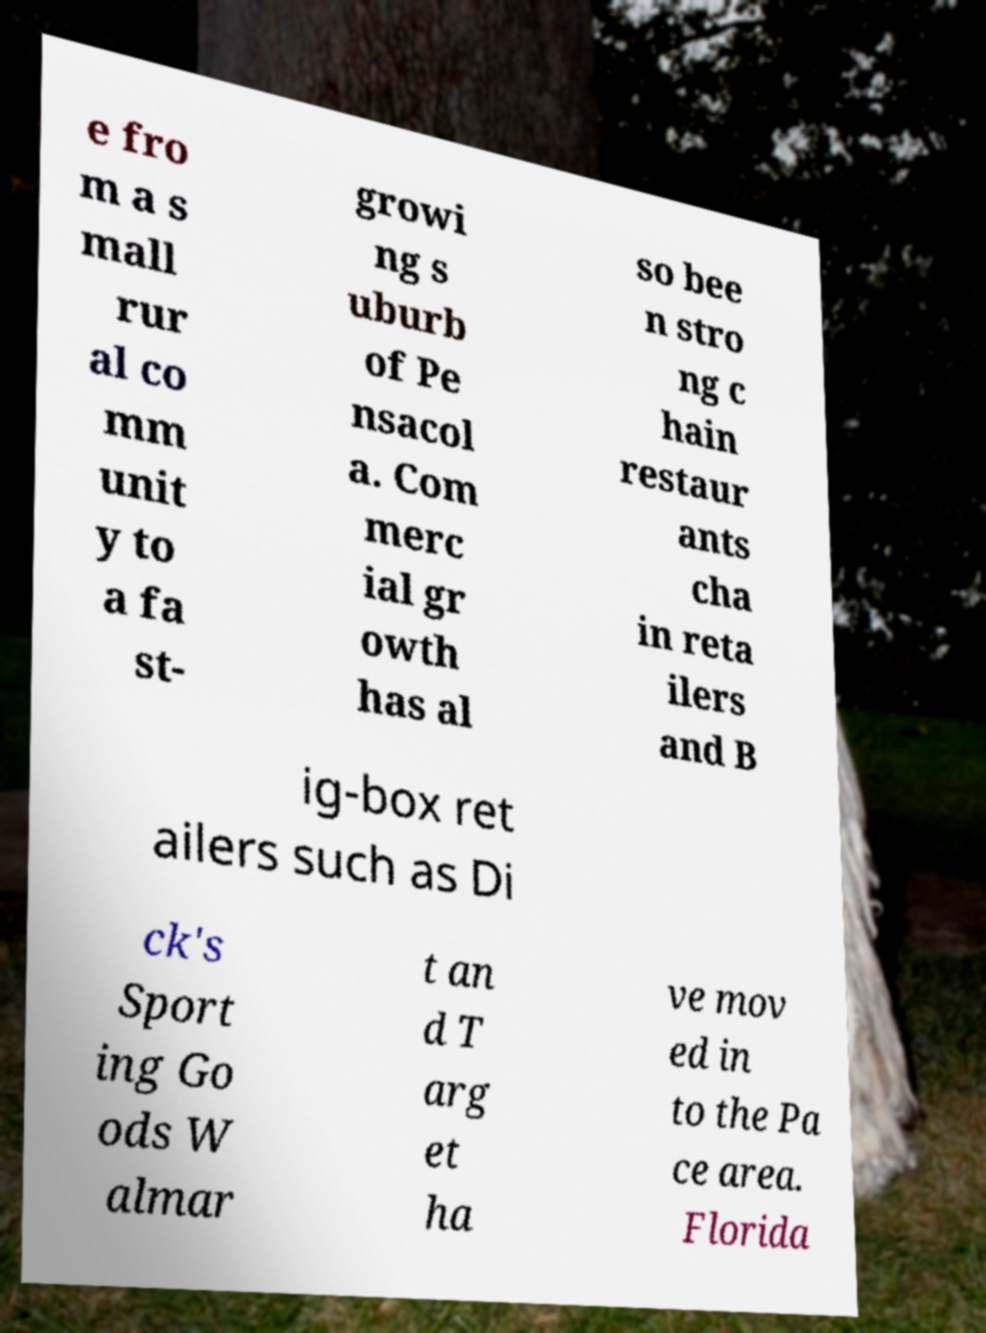Please identify and transcribe the text found in this image. e fro m a s mall rur al co mm unit y to a fa st- growi ng s uburb of Pe nsacol a. Com merc ial gr owth has al so bee n stro ng c hain restaur ants cha in reta ilers and B ig-box ret ailers such as Di ck's Sport ing Go ods W almar t an d T arg et ha ve mov ed in to the Pa ce area. Florida 